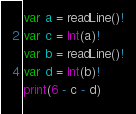<code> <loc_0><loc_0><loc_500><loc_500><_Swift_>var a = readLine()!
var c = Int(a)!
var b = readLine()!
var d = Int(b)!
print(6 - c - d)</code> 